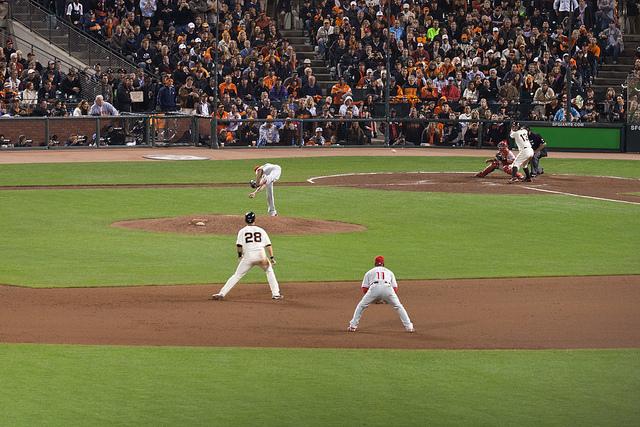What number Jersey is the guy wearing?
Short answer required. 28. How many umpires are there?
Short answer required. 1. What is the player in the middle doing?
Give a very brief answer. Pitching. What is the white and black player's number minus the red and gray player's number?
Quick response, please. 17. What sport are they playing?
Concise answer only. Baseball. 